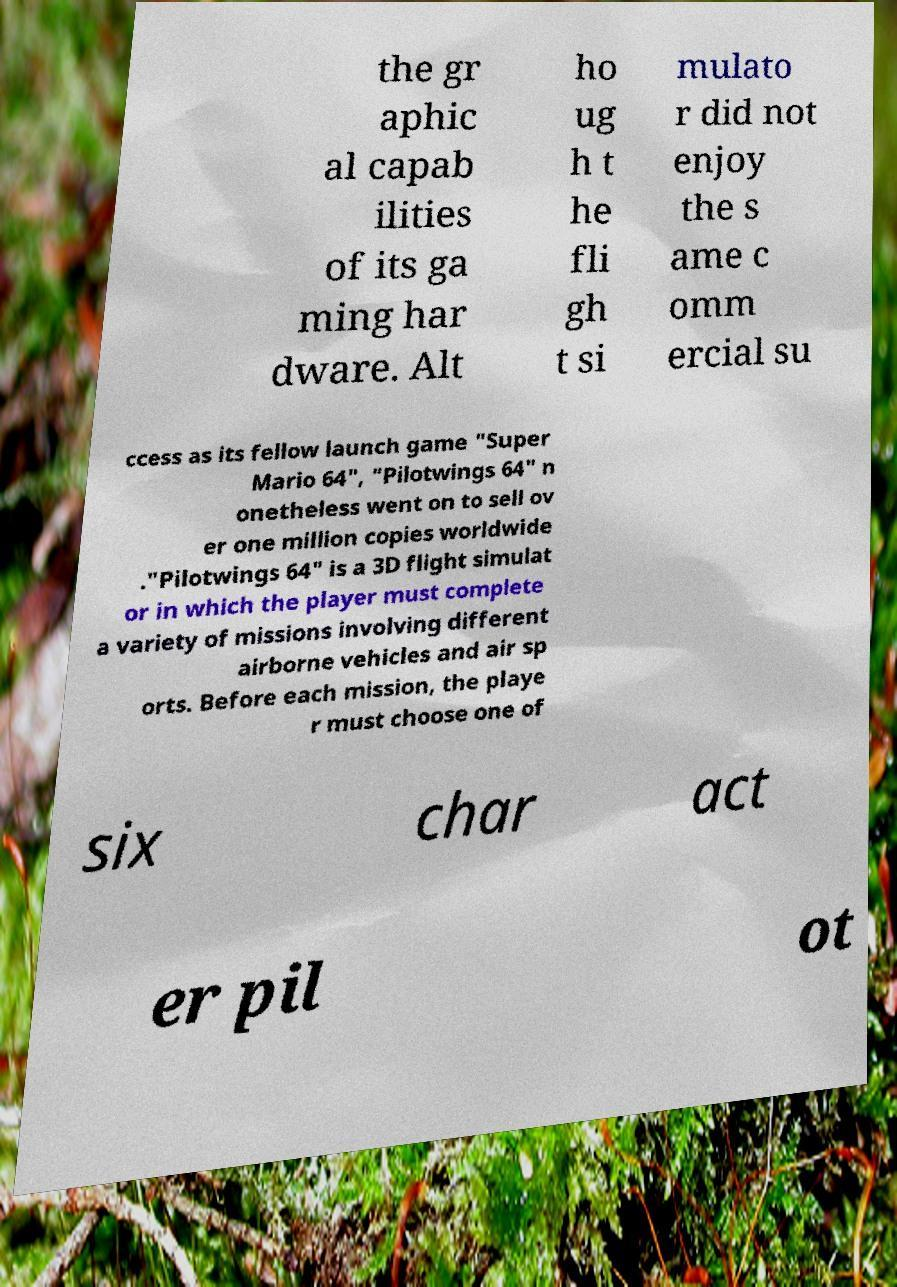Please identify and transcribe the text found in this image. the gr aphic al capab ilities of its ga ming har dware. Alt ho ug h t he fli gh t si mulato r did not enjoy the s ame c omm ercial su ccess as its fellow launch game "Super Mario 64", "Pilotwings 64" n onetheless went on to sell ov er one million copies worldwide ."Pilotwings 64" is a 3D flight simulat or in which the player must complete a variety of missions involving different airborne vehicles and air sp orts. Before each mission, the playe r must choose one of six char act er pil ot 